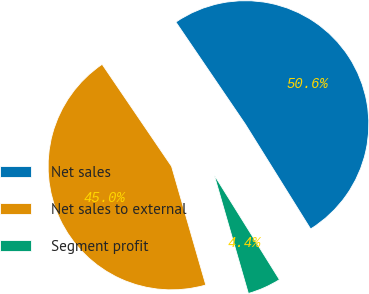Convert chart. <chart><loc_0><loc_0><loc_500><loc_500><pie_chart><fcel>Net sales<fcel>Net sales to external<fcel>Segment profit<nl><fcel>50.63%<fcel>44.96%<fcel>4.4%<nl></chart> 